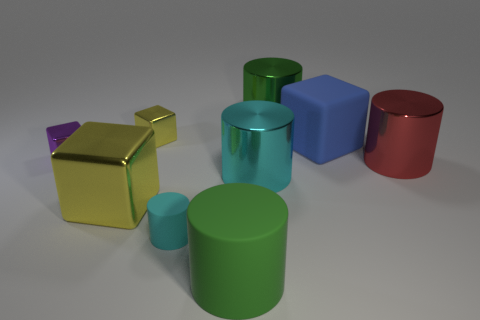There is a big blue thing that is the same shape as the tiny purple metal object; what is its material?
Your response must be concise. Rubber. Is there a brown rubber block?
Your response must be concise. No. What material is the big block that is on the left side of the green cylinder behind the small block that is to the left of the small yellow block made of?
Offer a terse response. Metal. There is a small purple metal object; is it the same shape as the rubber thing that is to the right of the large green metallic object?
Ensure brevity in your answer.  Yes. What number of large gray shiny things are the same shape as the small cyan thing?
Keep it short and to the point. 0. What is the shape of the large blue rubber object?
Your answer should be very brief. Cube. There is a green cylinder behind the block that is in front of the cyan metal thing; what is its size?
Your answer should be very brief. Large. What number of objects are large rubber objects or big cylinders?
Make the answer very short. 5. Do the small purple metal object and the large blue thing have the same shape?
Give a very brief answer. Yes. Is there a tiny cyan object that has the same material as the big yellow object?
Provide a succinct answer. No. 